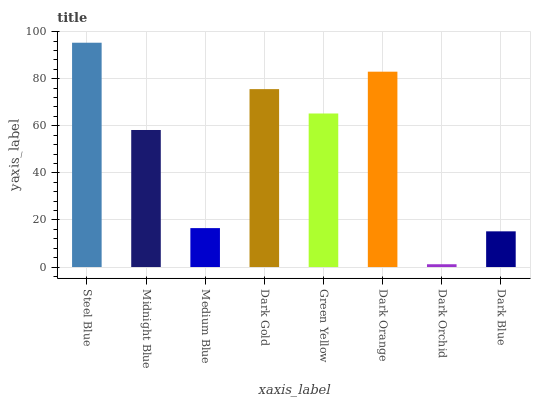Is Midnight Blue the minimum?
Answer yes or no. No. Is Midnight Blue the maximum?
Answer yes or no. No. Is Steel Blue greater than Midnight Blue?
Answer yes or no. Yes. Is Midnight Blue less than Steel Blue?
Answer yes or no. Yes. Is Midnight Blue greater than Steel Blue?
Answer yes or no. No. Is Steel Blue less than Midnight Blue?
Answer yes or no. No. Is Green Yellow the high median?
Answer yes or no. Yes. Is Midnight Blue the low median?
Answer yes or no. Yes. Is Midnight Blue the high median?
Answer yes or no. No. Is Dark Orchid the low median?
Answer yes or no. No. 